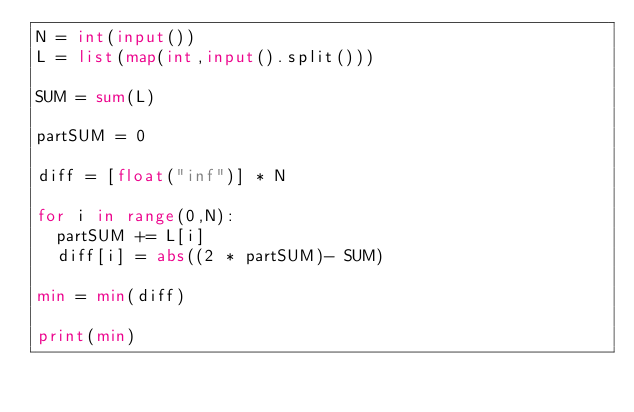Convert code to text. <code><loc_0><loc_0><loc_500><loc_500><_Python_>N = int(input())
L = list(map(int,input().split()))

SUM = sum(L)

partSUM = 0

diff = [float("inf")] * N

for i in range(0,N):
	partSUM += L[i]
	diff[i] = abs((2 * partSUM)- SUM)

min = min(diff)

print(min)</code> 